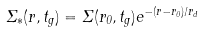Convert formula to latex. <formula><loc_0><loc_0><loc_500><loc_500>\Sigma _ { * } ( r , t _ { g } ) = \Sigma ( r _ { 0 } , t _ { g } ) e ^ { - ( r - r _ { 0 } ) / r _ { d } }</formula> 